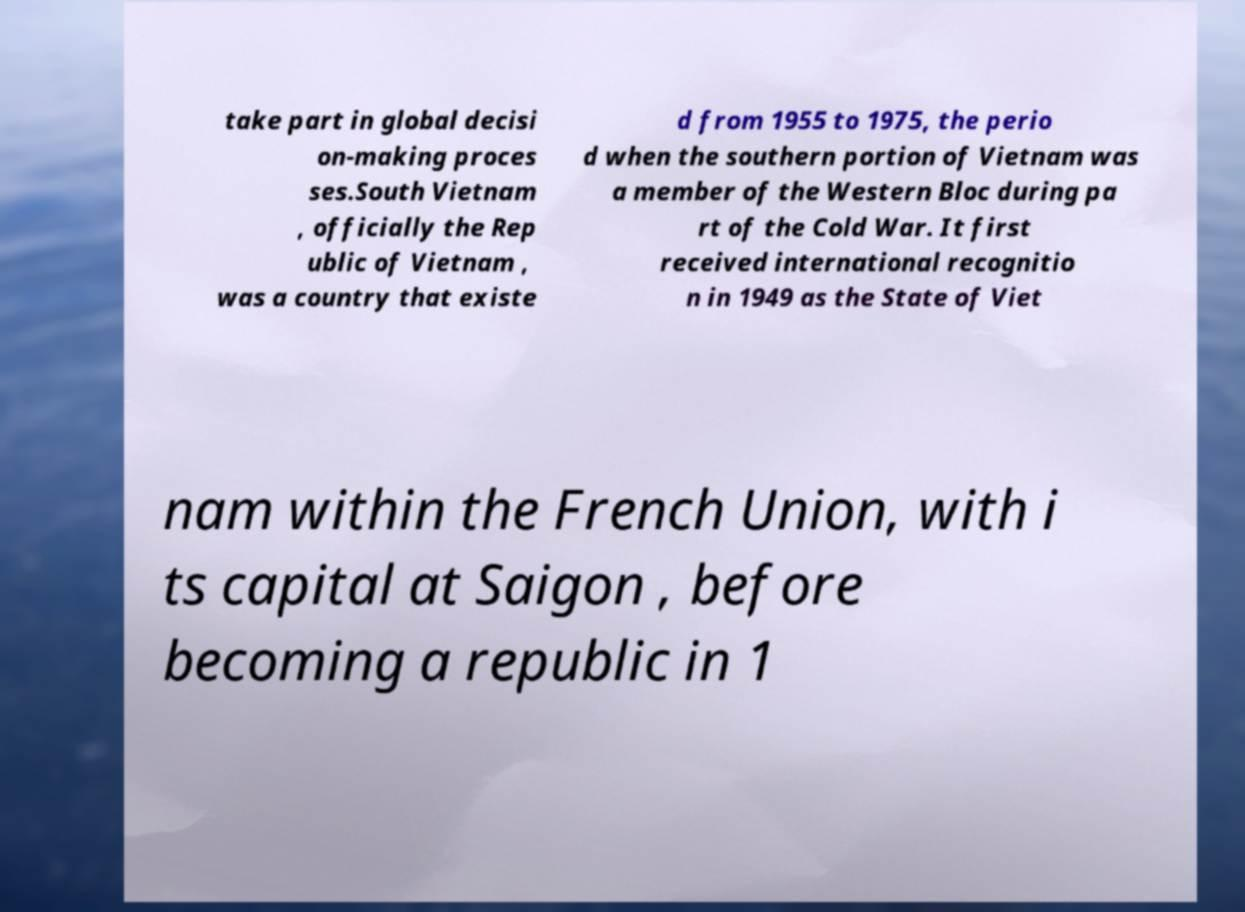Please identify and transcribe the text found in this image. take part in global decisi on-making proces ses.South Vietnam , officially the Rep ublic of Vietnam , was a country that existe d from 1955 to 1975, the perio d when the southern portion of Vietnam was a member of the Western Bloc during pa rt of the Cold War. It first received international recognitio n in 1949 as the State of Viet nam within the French Union, with i ts capital at Saigon , before becoming a republic in 1 